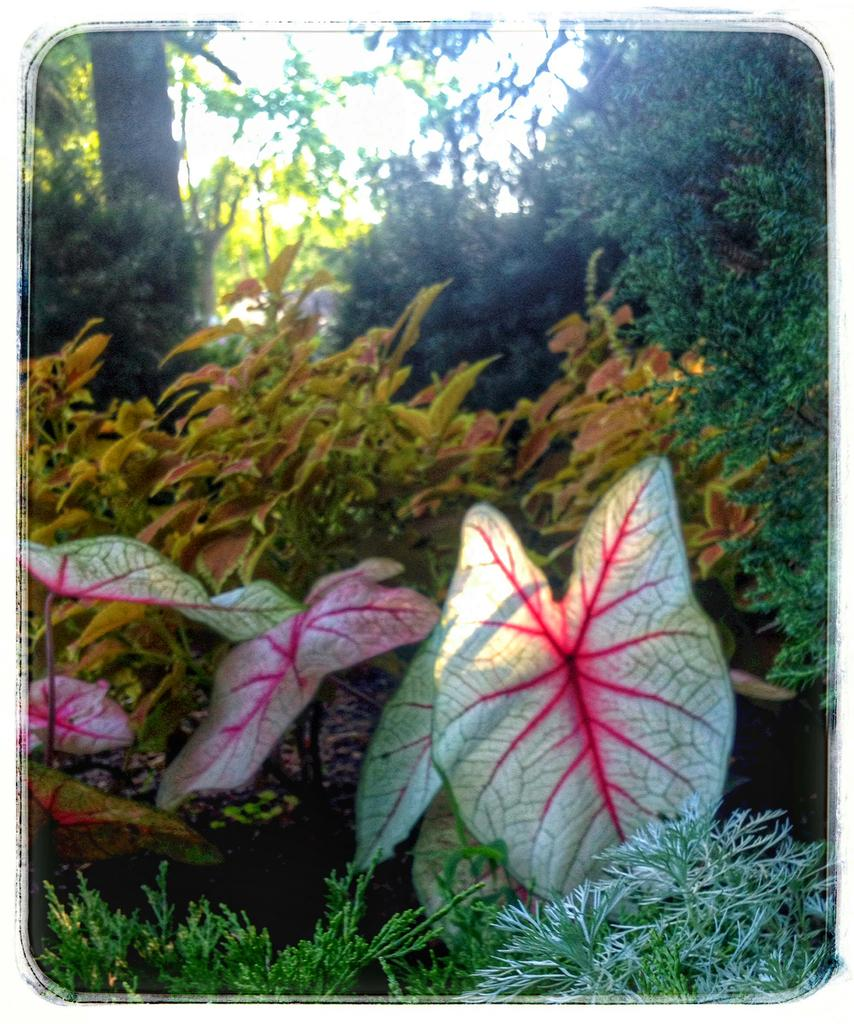What type of vegetation can be seen in the image? There are plants and trees in the image. Can you describe the specific types of plants or trees? The specific types of plants or trees are not mentioned in the provided facts. What is the setting or environment of the image? The setting or environment of the image is not specified, but the presence of plants and trees suggests it may be outdoors or in a natural setting. What type of cave can be seen in the image? There is no cave present in the image; it features plants and trees. What is the zinc content of the plants in the image? The zinc content of the plants is not mentioned in the provided facts, and it is not possible to determine this information from the image alone. 